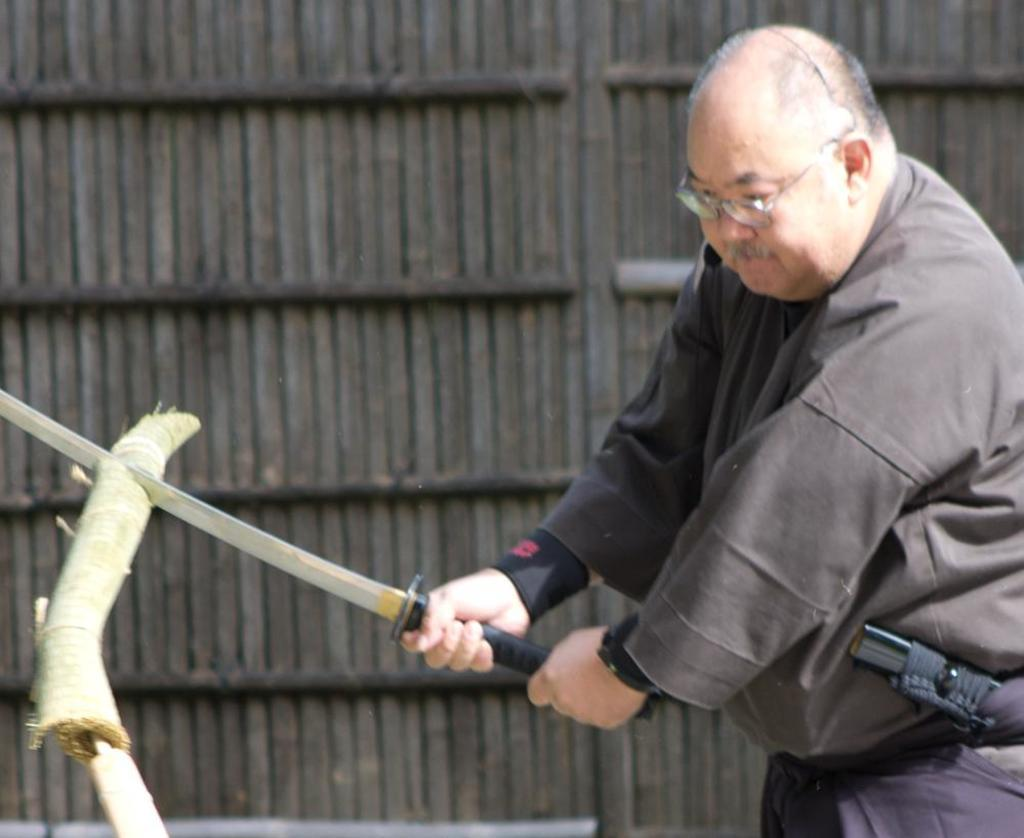What is the person in the image doing? The person is cutting wood. What tool is the person using to cut the wood? The person is using a sword to cut the wood. What can be seen in the background of the image? There is a wooden wall in the image. What type of wave can be seen in the image? There is no wave present in the image; it features a person cutting wood with a sword and a wooden wall in the background. 